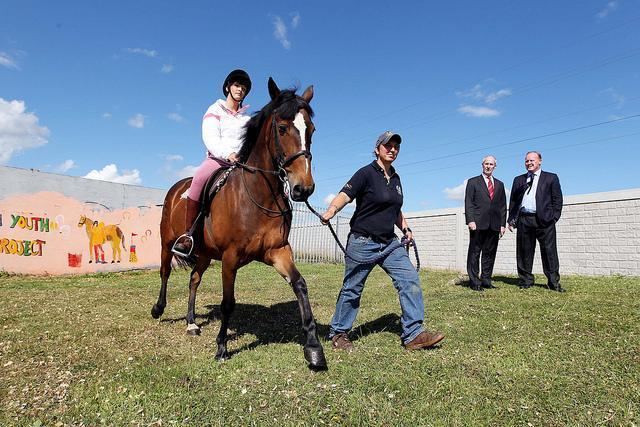How many people are visible?
Give a very brief answer. 4. How many people are standing outside the train in the image?
Give a very brief answer. 0. 